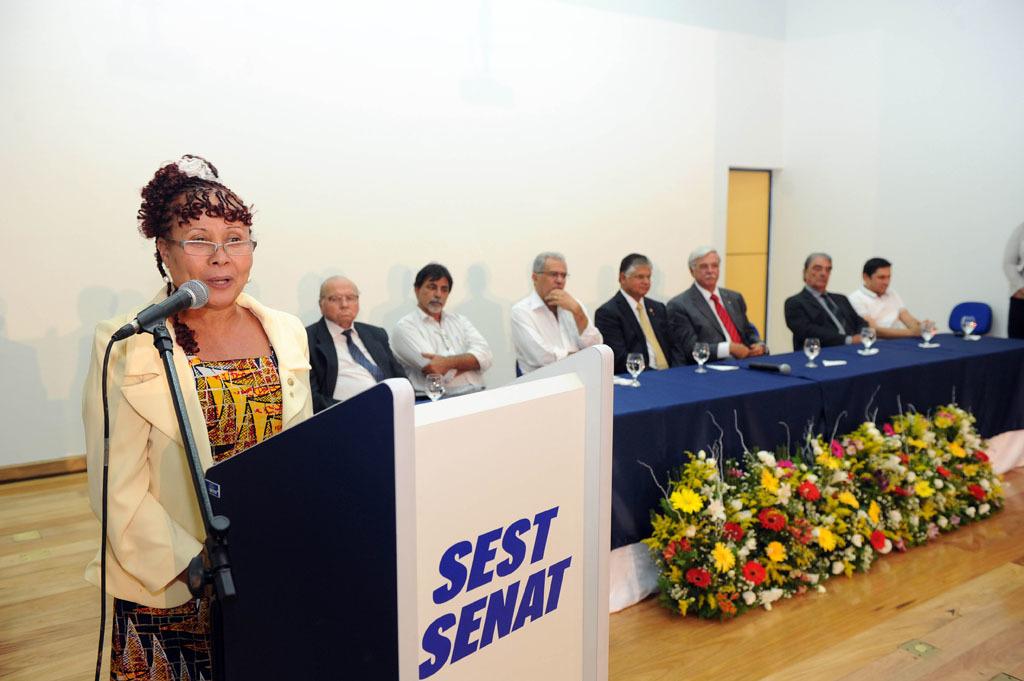What does it say on the front of the podium?
Offer a very short reply. Sest senat. 